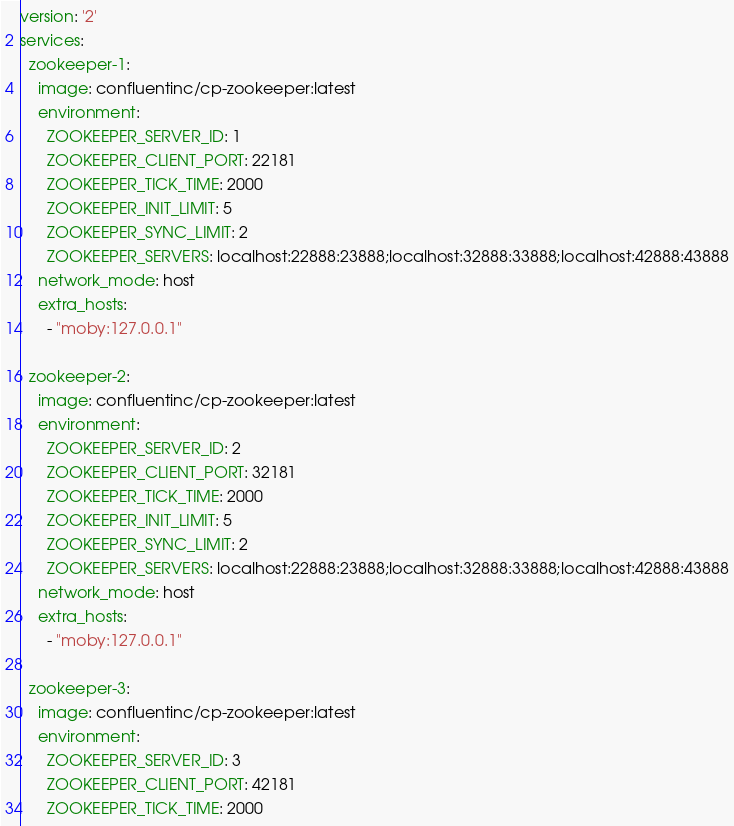<code> <loc_0><loc_0><loc_500><loc_500><_YAML_>version: '2'
services:
  zookeeper-1:
    image: confluentinc/cp-zookeeper:latest
    environment:
      ZOOKEEPER_SERVER_ID: 1
      ZOOKEEPER_CLIENT_PORT: 22181
      ZOOKEEPER_TICK_TIME: 2000
      ZOOKEEPER_INIT_LIMIT: 5
      ZOOKEEPER_SYNC_LIMIT: 2
      ZOOKEEPER_SERVERS: localhost:22888:23888;localhost:32888:33888;localhost:42888:43888
    network_mode: host
    extra_hosts:
      - "moby:127.0.0.1"

  zookeeper-2:
    image: confluentinc/cp-zookeeper:latest
    environment:
      ZOOKEEPER_SERVER_ID: 2
      ZOOKEEPER_CLIENT_PORT: 32181
      ZOOKEEPER_TICK_TIME: 2000
      ZOOKEEPER_INIT_LIMIT: 5
      ZOOKEEPER_SYNC_LIMIT: 2
      ZOOKEEPER_SERVERS: localhost:22888:23888;localhost:32888:33888;localhost:42888:43888
    network_mode: host
    extra_hosts:
      - "moby:127.0.0.1"

  zookeeper-3:
    image: confluentinc/cp-zookeeper:latest
    environment:
      ZOOKEEPER_SERVER_ID: 3
      ZOOKEEPER_CLIENT_PORT: 42181
      ZOOKEEPER_TICK_TIME: 2000</code> 